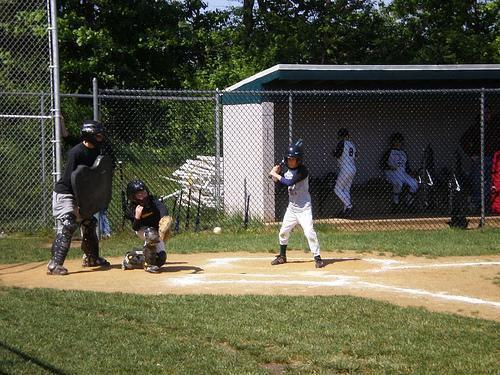How many players on the field?
Give a very brief answer. 3. How many batters are pictured?
Give a very brief answer. 1. How many balls are pictured?
Give a very brief answer. 1. How many people are on the field?
Give a very brief answer. 3. How many players can be seen in the dugout?
Give a very brief answer. 2. 